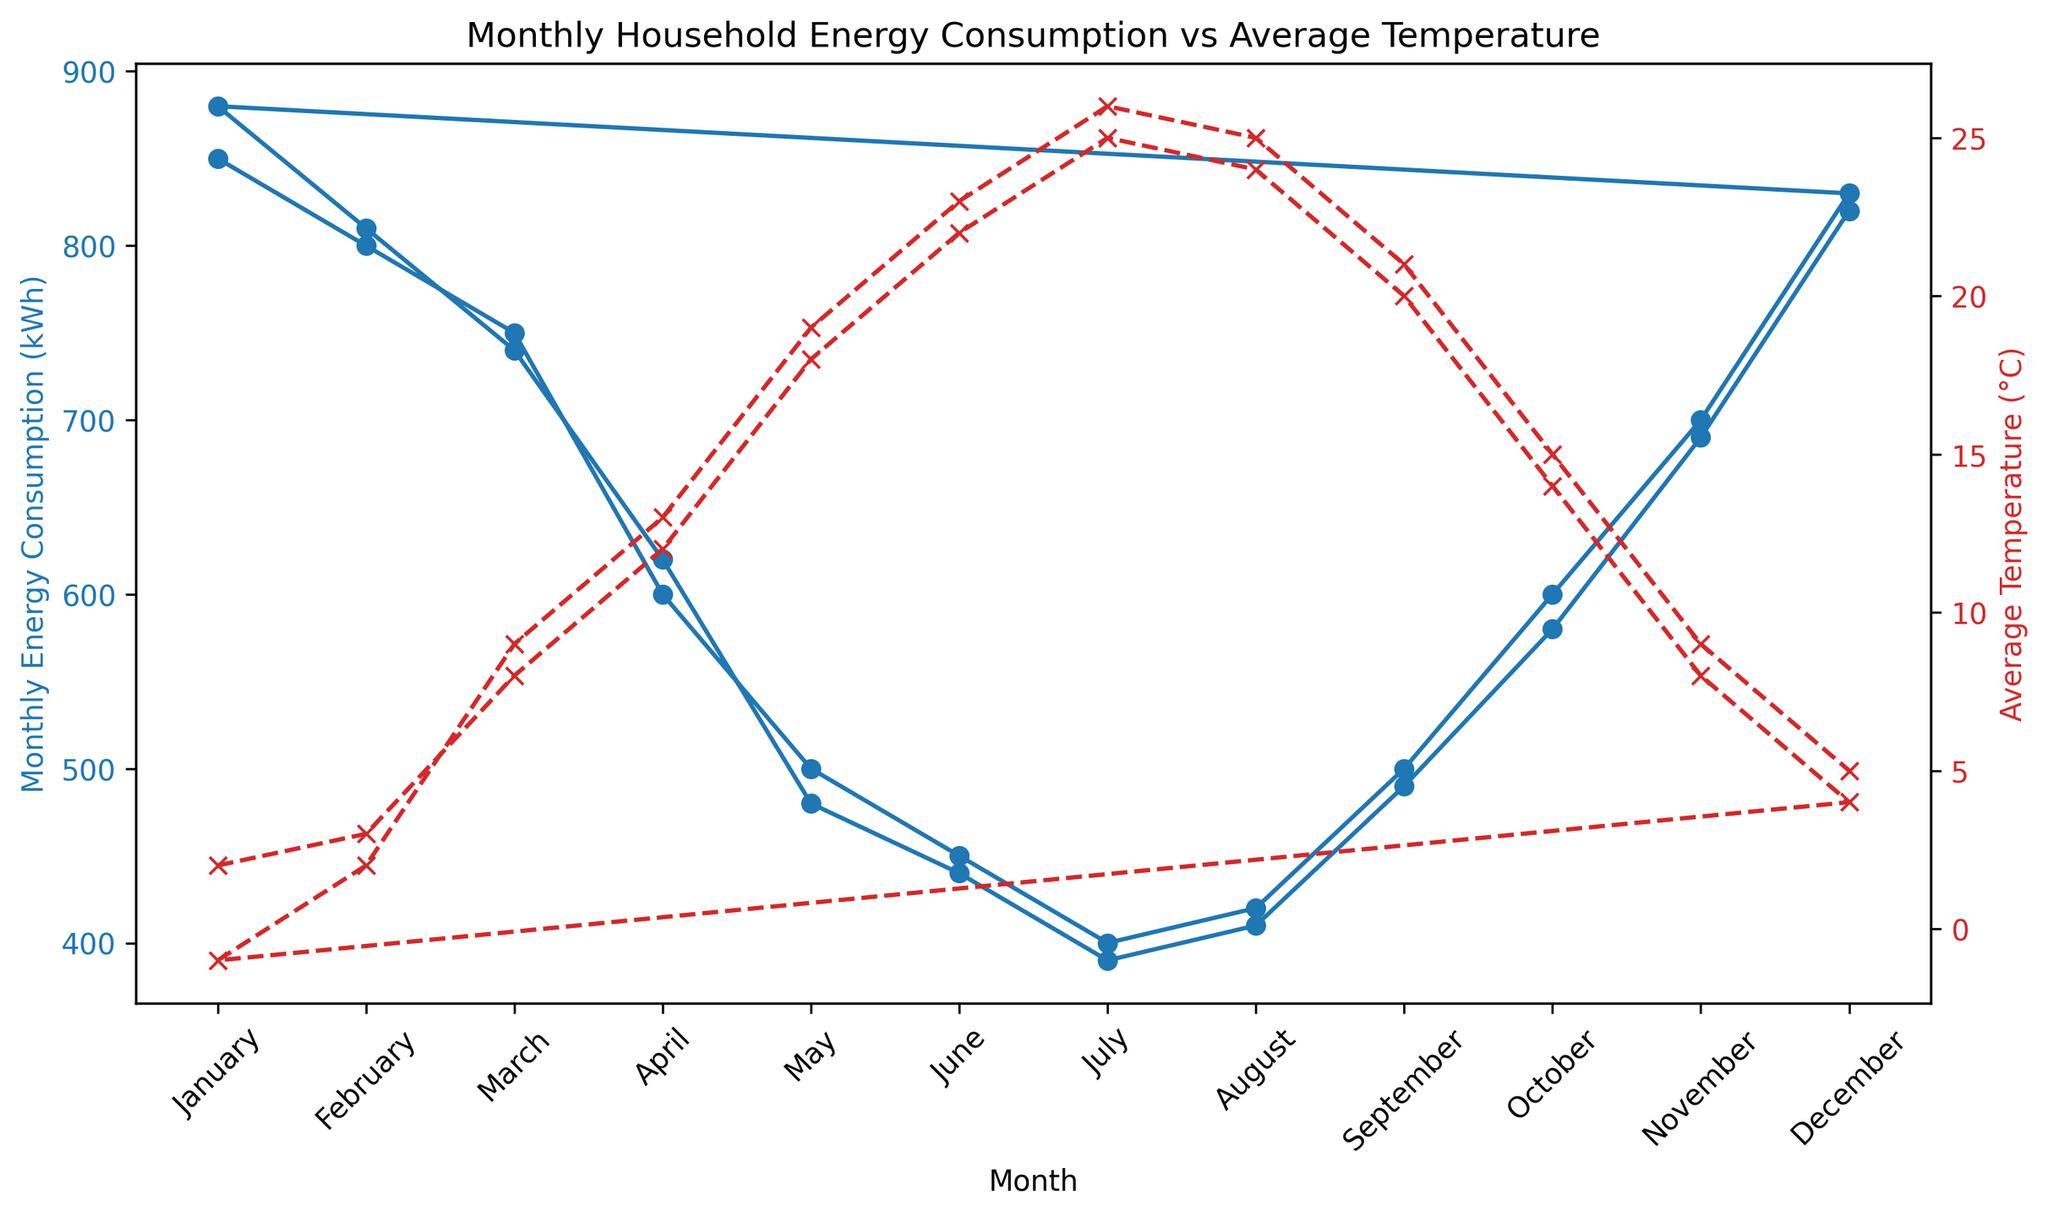Which month had the highest average temperature? To determine which month had the highest average temperature, look at the secondary y-axis representing temperature (red line with x markers) and identify the peak point. The highest point is in July, with a reading of 26°C.
Answer: July What is the difference in monthly energy consumption between the months with the highest and lowest average temperature? First, identify the months with the highest (July, 26°C) and lowest (-1°C, January) average temperatures. Then note their energy consumption values: July (390 kWh) and January (880 kWh). The difference is 880 kWh - 390 kWh = 490 kWh.
Answer: 490 kWh Which month shows the largest drop in average temperature from the previous month? To identify this, look at the red line with x markers between consecutive months and spot the steepest downward slope. The drop from September to October seems noticeable (21°C to 15°C), resulting in a drop of 6°C.
Answer: October In which month is the visual disparity between energy consumption and average temperature the greatest? Look for the month where the blue line (energy consumption) and red line (temperature) visually diverge the most. December shows this, where energy consumption is high (820 kWh) despite a relatively low temperature (5°C).
Answer: December What is the average energy consumption across all months displayed in the figure? To find the average, add up the energy consumptions for each month and divide by the total number of data points. Sum: (850+800+750+600+500+450+400+420+500+600+700+830+880+810+740+620+480+440+390+410+490+580+690+820) = 16160. Number of data points: 24. Average: 16160 / 24 = 673.33 kWh approximately.
Answer: 673.33 kWh How does the average temperature in April compare to the average temperature in October? Identify the temperature values for April (12°C) and October (15°C) and compare them. April's temperature is lower by 3°C compared to October's.
Answer: October is 3°C warmer Is there a general trend between energy consumption and temperature across the months? By visually inspecting the blue and red lines, you can observe that, in general, higher temperatures (summer months) correspond to lower energy consumption and vice versa, indicating an inverse relationship.
Answer: Inverse relationship During which months does the energy consumption match exactly with one from another month? List those pairs. By looking at the blue line and identifying nodes that have matching values in kWh: Energy consumption of 500 kWh occurs in May and September.
Answer: May and September 